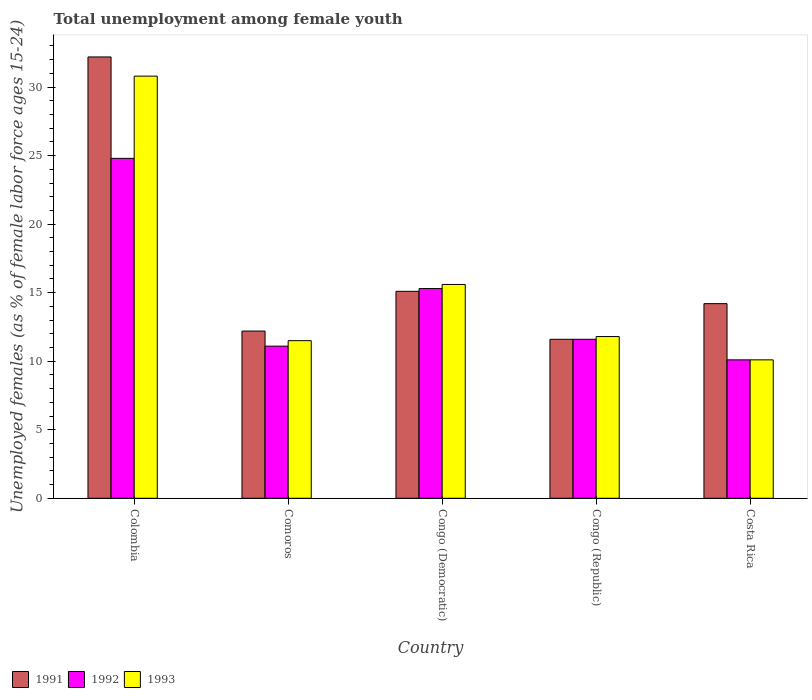How many groups of bars are there?
Offer a very short reply. 5. Are the number of bars per tick equal to the number of legend labels?
Provide a succinct answer. Yes. How many bars are there on the 2nd tick from the left?
Make the answer very short. 3. How many bars are there on the 4th tick from the right?
Provide a succinct answer. 3. What is the label of the 5th group of bars from the left?
Keep it short and to the point. Costa Rica. What is the percentage of unemployed females in in 1991 in Colombia?
Ensure brevity in your answer.  32.2. Across all countries, what is the maximum percentage of unemployed females in in 1991?
Give a very brief answer. 32.2. Across all countries, what is the minimum percentage of unemployed females in in 1992?
Provide a succinct answer. 10.1. In which country was the percentage of unemployed females in in 1993 minimum?
Your answer should be very brief. Costa Rica. What is the total percentage of unemployed females in in 1992 in the graph?
Keep it short and to the point. 72.9. What is the difference between the percentage of unemployed females in in 1992 in Congo (Democratic) and that in Congo (Republic)?
Provide a short and direct response. 3.7. What is the difference between the percentage of unemployed females in in 1993 in Congo (Democratic) and the percentage of unemployed females in in 1991 in Costa Rica?
Make the answer very short. 1.4. What is the average percentage of unemployed females in in 1991 per country?
Give a very brief answer. 17.06. What is the ratio of the percentage of unemployed females in in 1993 in Congo (Republic) to that in Costa Rica?
Offer a very short reply. 1.17. Is the percentage of unemployed females in in 1993 in Congo (Democratic) less than that in Congo (Republic)?
Provide a succinct answer. No. Is the difference between the percentage of unemployed females in in 1993 in Comoros and Congo (Republic) greater than the difference between the percentage of unemployed females in in 1992 in Comoros and Congo (Republic)?
Make the answer very short. Yes. What is the difference between the highest and the second highest percentage of unemployed females in in 1991?
Offer a very short reply. 18. What is the difference between the highest and the lowest percentage of unemployed females in in 1993?
Offer a very short reply. 20.7. What does the 2nd bar from the right in Costa Rica represents?
Make the answer very short. 1992. How many bars are there?
Keep it short and to the point. 15. What is the difference between two consecutive major ticks on the Y-axis?
Provide a short and direct response. 5. Are the values on the major ticks of Y-axis written in scientific E-notation?
Give a very brief answer. No. Does the graph contain any zero values?
Offer a very short reply. No. Does the graph contain grids?
Provide a short and direct response. No. How many legend labels are there?
Offer a very short reply. 3. What is the title of the graph?
Keep it short and to the point. Total unemployment among female youth. Does "1961" appear as one of the legend labels in the graph?
Make the answer very short. No. What is the label or title of the Y-axis?
Your answer should be compact. Unemployed females (as % of female labor force ages 15-24). What is the Unemployed females (as % of female labor force ages 15-24) in 1991 in Colombia?
Your answer should be very brief. 32.2. What is the Unemployed females (as % of female labor force ages 15-24) of 1992 in Colombia?
Provide a succinct answer. 24.8. What is the Unemployed females (as % of female labor force ages 15-24) in 1993 in Colombia?
Your response must be concise. 30.8. What is the Unemployed females (as % of female labor force ages 15-24) of 1991 in Comoros?
Offer a very short reply. 12.2. What is the Unemployed females (as % of female labor force ages 15-24) in 1992 in Comoros?
Your response must be concise. 11.1. What is the Unemployed females (as % of female labor force ages 15-24) of 1993 in Comoros?
Offer a terse response. 11.5. What is the Unemployed females (as % of female labor force ages 15-24) of 1991 in Congo (Democratic)?
Your answer should be compact. 15.1. What is the Unemployed females (as % of female labor force ages 15-24) in 1992 in Congo (Democratic)?
Offer a very short reply. 15.3. What is the Unemployed females (as % of female labor force ages 15-24) in 1993 in Congo (Democratic)?
Offer a very short reply. 15.6. What is the Unemployed females (as % of female labor force ages 15-24) of 1991 in Congo (Republic)?
Ensure brevity in your answer.  11.6. What is the Unemployed females (as % of female labor force ages 15-24) of 1992 in Congo (Republic)?
Offer a very short reply. 11.6. What is the Unemployed females (as % of female labor force ages 15-24) in 1993 in Congo (Republic)?
Give a very brief answer. 11.8. What is the Unemployed females (as % of female labor force ages 15-24) of 1991 in Costa Rica?
Ensure brevity in your answer.  14.2. What is the Unemployed females (as % of female labor force ages 15-24) of 1992 in Costa Rica?
Your answer should be very brief. 10.1. What is the Unemployed females (as % of female labor force ages 15-24) of 1993 in Costa Rica?
Give a very brief answer. 10.1. Across all countries, what is the maximum Unemployed females (as % of female labor force ages 15-24) in 1991?
Provide a succinct answer. 32.2. Across all countries, what is the maximum Unemployed females (as % of female labor force ages 15-24) in 1992?
Provide a succinct answer. 24.8. Across all countries, what is the maximum Unemployed females (as % of female labor force ages 15-24) of 1993?
Give a very brief answer. 30.8. Across all countries, what is the minimum Unemployed females (as % of female labor force ages 15-24) of 1991?
Your response must be concise. 11.6. Across all countries, what is the minimum Unemployed females (as % of female labor force ages 15-24) of 1992?
Provide a short and direct response. 10.1. Across all countries, what is the minimum Unemployed females (as % of female labor force ages 15-24) in 1993?
Your response must be concise. 10.1. What is the total Unemployed females (as % of female labor force ages 15-24) in 1991 in the graph?
Give a very brief answer. 85.3. What is the total Unemployed females (as % of female labor force ages 15-24) in 1992 in the graph?
Your answer should be compact. 72.9. What is the total Unemployed females (as % of female labor force ages 15-24) in 1993 in the graph?
Provide a succinct answer. 79.8. What is the difference between the Unemployed females (as % of female labor force ages 15-24) of 1992 in Colombia and that in Comoros?
Make the answer very short. 13.7. What is the difference between the Unemployed females (as % of female labor force ages 15-24) of 1993 in Colombia and that in Comoros?
Offer a terse response. 19.3. What is the difference between the Unemployed females (as % of female labor force ages 15-24) in 1993 in Colombia and that in Congo (Democratic)?
Ensure brevity in your answer.  15.2. What is the difference between the Unemployed females (as % of female labor force ages 15-24) of 1991 in Colombia and that in Congo (Republic)?
Give a very brief answer. 20.6. What is the difference between the Unemployed females (as % of female labor force ages 15-24) in 1993 in Colombia and that in Congo (Republic)?
Keep it short and to the point. 19. What is the difference between the Unemployed females (as % of female labor force ages 15-24) in 1991 in Colombia and that in Costa Rica?
Give a very brief answer. 18. What is the difference between the Unemployed females (as % of female labor force ages 15-24) in 1992 in Colombia and that in Costa Rica?
Your answer should be compact. 14.7. What is the difference between the Unemployed females (as % of female labor force ages 15-24) of 1993 in Colombia and that in Costa Rica?
Make the answer very short. 20.7. What is the difference between the Unemployed females (as % of female labor force ages 15-24) of 1993 in Comoros and that in Congo (Democratic)?
Offer a very short reply. -4.1. What is the difference between the Unemployed females (as % of female labor force ages 15-24) in 1991 in Comoros and that in Congo (Republic)?
Your response must be concise. 0.6. What is the difference between the Unemployed females (as % of female labor force ages 15-24) of 1992 in Comoros and that in Congo (Republic)?
Make the answer very short. -0.5. What is the difference between the Unemployed females (as % of female labor force ages 15-24) of 1991 in Congo (Democratic) and that in Congo (Republic)?
Provide a succinct answer. 3.5. What is the difference between the Unemployed females (as % of female labor force ages 15-24) of 1992 in Congo (Democratic) and that in Congo (Republic)?
Give a very brief answer. 3.7. What is the difference between the Unemployed females (as % of female labor force ages 15-24) of 1991 in Congo (Democratic) and that in Costa Rica?
Provide a succinct answer. 0.9. What is the difference between the Unemployed females (as % of female labor force ages 15-24) in 1992 in Congo (Democratic) and that in Costa Rica?
Your response must be concise. 5.2. What is the difference between the Unemployed females (as % of female labor force ages 15-24) of 1993 in Congo (Democratic) and that in Costa Rica?
Your response must be concise. 5.5. What is the difference between the Unemployed females (as % of female labor force ages 15-24) in 1991 in Congo (Republic) and that in Costa Rica?
Offer a very short reply. -2.6. What is the difference between the Unemployed females (as % of female labor force ages 15-24) in 1991 in Colombia and the Unemployed females (as % of female labor force ages 15-24) in 1992 in Comoros?
Your answer should be very brief. 21.1. What is the difference between the Unemployed females (as % of female labor force ages 15-24) of 1991 in Colombia and the Unemployed females (as % of female labor force ages 15-24) of 1993 in Comoros?
Your answer should be compact. 20.7. What is the difference between the Unemployed females (as % of female labor force ages 15-24) in 1992 in Colombia and the Unemployed females (as % of female labor force ages 15-24) in 1993 in Comoros?
Your response must be concise. 13.3. What is the difference between the Unemployed females (as % of female labor force ages 15-24) in 1991 in Colombia and the Unemployed females (as % of female labor force ages 15-24) in 1993 in Congo (Democratic)?
Offer a very short reply. 16.6. What is the difference between the Unemployed females (as % of female labor force ages 15-24) in 1992 in Colombia and the Unemployed females (as % of female labor force ages 15-24) in 1993 in Congo (Democratic)?
Provide a succinct answer. 9.2. What is the difference between the Unemployed females (as % of female labor force ages 15-24) of 1991 in Colombia and the Unemployed females (as % of female labor force ages 15-24) of 1992 in Congo (Republic)?
Your response must be concise. 20.6. What is the difference between the Unemployed females (as % of female labor force ages 15-24) in 1991 in Colombia and the Unemployed females (as % of female labor force ages 15-24) in 1993 in Congo (Republic)?
Give a very brief answer. 20.4. What is the difference between the Unemployed females (as % of female labor force ages 15-24) in 1992 in Colombia and the Unemployed females (as % of female labor force ages 15-24) in 1993 in Congo (Republic)?
Give a very brief answer. 13. What is the difference between the Unemployed females (as % of female labor force ages 15-24) in 1991 in Colombia and the Unemployed females (as % of female labor force ages 15-24) in 1992 in Costa Rica?
Offer a terse response. 22.1. What is the difference between the Unemployed females (as % of female labor force ages 15-24) of 1991 in Colombia and the Unemployed females (as % of female labor force ages 15-24) of 1993 in Costa Rica?
Provide a succinct answer. 22.1. What is the difference between the Unemployed females (as % of female labor force ages 15-24) of 1991 in Comoros and the Unemployed females (as % of female labor force ages 15-24) of 1992 in Congo (Democratic)?
Ensure brevity in your answer.  -3.1. What is the difference between the Unemployed females (as % of female labor force ages 15-24) of 1992 in Comoros and the Unemployed females (as % of female labor force ages 15-24) of 1993 in Congo (Democratic)?
Your response must be concise. -4.5. What is the difference between the Unemployed females (as % of female labor force ages 15-24) of 1991 in Comoros and the Unemployed females (as % of female labor force ages 15-24) of 1992 in Congo (Republic)?
Your answer should be very brief. 0.6. What is the difference between the Unemployed females (as % of female labor force ages 15-24) of 1991 in Comoros and the Unemployed females (as % of female labor force ages 15-24) of 1993 in Costa Rica?
Offer a very short reply. 2.1. What is the difference between the Unemployed females (as % of female labor force ages 15-24) of 1991 in Congo (Democratic) and the Unemployed females (as % of female labor force ages 15-24) of 1993 in Congo (Republic)?
Keep it short and to the point. 3.3. What is the difference between the Unemployed females (as % of female labor force ages 15-24) in 1992 in Congo (Democratic) and the Unemployed females (as % of female labor force ages 15-24) in 1993 in Costa Rica?
Give a very brief answer. 5.2. What is the difference between the Unemployed females (as % of female labor force ages 15-24) of 1991 in Congo (Republic) and the Unemployed females (as % of female labor force ages 15-24) of 1993 in Costa Rica?
Provide a succinct answer. 1.5. What is the average Unemployed females (as % of female labor force ages 15-24) in 1991 per country?
Keep it short and to the point. 17.06. What is the average Unemployed females (as % of female labor force ages 15-24) in 1992 per country?
Ensure brevity in your answer.  14.58. What is the average Unemployed females (as % of female labor force ages 15-24) of 1993 per country?
Your answer should be very brief. 15.96. What is the difference between the Unemployed females (as % of female labor force ages 15-24) in 1991 and Unemployed females (as % of female labor force ages 15-24) in 1992 in Colombia?
Give a very brief answer. 7.4. What is the difference between the Unemployed females (as % of female labor force ages 15-24) of 1992 and Unemployed females (as % of female labor force ages 15-24) of 1993 in Colombia?
Your answer should be compact. -6. What is the difference between the Unemployed females (as % of female labor force ages 15-24) of 1991 and Unemployed females (as % of female labor force ages 15-24) of 1993 in Comoros?
Your response must be concise. 0.7. What is the difference between the Unemployed females (as % of female labor force ages 15-24) in 1992 and Unemployed females (as % of female labor force ages 15-24) in 1993 in Comoros?
Provide a succinct answer. -0.4. What is the difference between the Unemployed females (as % of female labor force ages 15-24) of 1991 and Unemployed females (as % of female labor force ages 15-24) of 1992 in Congo (Democratic)?
Make the answer very short. -0.2. What is the difference between the Unemployed females (as % of female labor force ages 15-24) of 1992 and Unemployed females (as % of female labor force ages 15-24) of 1993 in Congo (Democratic)?
Keep it short and to the point. -0.3. What is the difference between the Unemployed females (as % of female labor force ages 15-24) of 1991 and Unemployed females (as % of female labor force ages 15-24) of 1992 in Congo (Republic)?
Give a very brief answer. 0. What is the difference between the Unemployed females (as % of female labor force ages 15-24) in 1991 and Unemployed females (as % of female labor force ages 15-24) in 1992 in Costa Rica?
Ensure brevity in your answer.  4.1. What is the difference between the Unemployed females (as % of female labor force ages 15-24) of 1991 and Unemployed females (as % of female labor force ages 15-24) of 1993 in Costa Rica?
Your answer should be compact. 4.1. What is the difference between the Unemployed females (as % of female labor force ages 15-24) in 1992 and Unemployed females (as % of female labor force ages 15-24) in 1993 in Costa Rica?
Keep it short and to the point. 0. What is the ratio of the Unemployed females (as % of female labor force ages 15-24) in 1991 in Colombia to that in Comoros?
Your response must be concise. 2.64. What is the ratio of the Unemployed females (as % of female labor force ages 15-24) in 1992 in Colombia to that in Comoros?
Provide a short and direct response. 2.23. What is the ratio of the Unemployed females (as % of female labor force ages 15-24) in 1993 in Colombia to that in Comoros?
Provide a succinct answer. 2.68. What is the ratio of the Unemployed females (as % of female labor force ages 15-24) of 1991 in Colombia to that in Congo (Democratic)?
Offer a very short reply. 2.13. What is the ratio of the Unemployed females (as % of female labor force ages 15-24) of 1992 in Colombia to that in Congo (Democratic)?
Offer a terse response. 1.62. What is the ratio of the Unemployed females (as % of female labor force ages 15-24) of 1993 in Colombia to that in Congo (Democratic)?
Provide a short and direct response. 1.97. What is the ratio of the Unemployed females (as % of female labor force ages 15-24) in 1991 in Colombia to that in Congo (Republic)?
Offer a terse response. 2.78. What is the ratio of the Unemployed females (as % of female labor force ages 15-24) in 1992 in Colombia to that in Congo (Republic)?
Provide a short and direct response. 2.14. What is the ratio of the Unemployed females (as % of female labor force ages 15-24) of 1993 in Colombia to that in Congo (Republic)?
Ensure brevity in your answer.  2.61. What is the ratio of the Unemployed females (as % of female labor force ages 15-24) in 1991 in Colombia to that in Costa Rica?
Offer a terse response. 2.27. What is the ratio of the Unemployed females (as % of female labor force ages 15-24) of 1992 in Colombia to that in Costa Rica?
Provide a succinct answer. 2.46. What is the ratio of the Unemployed females (as % of female labor force ages 15-24) in 1993 in Colombia to that in Costa Rica?
Give a very brief answer. 3.05. What is the ratio of the Unemployed females (as % of female labor force ages 15-24) in 1991 in Comoros to that in Congo (Democratic)?
Your answer should be very brief. 0.81. What is the ratio of the Unemployed females (as % of female labor force ages 15-24) in 1992 in Comoros to that in Congo (Democratic)?
Keep it short and to the point. 0.73. What is the ratio of the Unemployed females (as % of female labor force ages 15-24) of 1993 in Comoros to that in Congo (Democratic)?
Keep it short and to the point. 0.74. What is the ratio of the Unemployed females (as % of female labor force ages 15-24) in 1991 in Comoros to that in Congo (Republic)?
Your response must be concise. 1.05. What is the ratio of the Unemployed females (as % of female labor force ages 15-24) of 1992 in Comoros to that in Congo (Republic)?
Provide a succinct answer. 0.96. What is the ratio of the Unemployed females (as % of female labor force ages 15-24) of 1993 in Comoros to that in Congo (Republic)?
Your answer should be very brief. 0.97. What is the ratio of the Unemployed females (as % of female labor force ages 15-24) in 1991 in Comoros to that in Costa Rica?
Ensure brevity in your answer.  0.86. What is the ratio of the Unemployed females (as % of female labor force ages 15-24) in 1992 in Comoros to that in Costa Rica?
Give a very brief answer. 1.1. What is the ratio of the Unemployed females (as % of female labor force ages 15-24) in 1993 in Comoros to that in Costa Rica?
Your answer should be very brief. 1.14. What is the ratio of the Unemployed females (as % of female labor force ages 15-24) in 1991 in Congo (Democratic) to that in Congo (Republic)?
Give a very brief answer. 1.3. What is the ratio of the Unemployed females (as % of female labor force ages 15-24) in 1992 in Congo (Democratic) to that in Congo (Republic)?
Your answer should be very brief. 1.32. What is the ratio of the Unemployed females (as % of female labor force ages 15-24) in 1993 in Congo (Democratic) to that in Congo (Republic)?
Give a very brief answer. 1.32. What is the ratio of the Unemployed females (as % of female labor force ages 15-24) of 1991 in Congo (Democratic) to that in Costa Rica?
Offer a very short reply. 1.06. What is the ratio of the Unemployed females (as % of female labor force ages 15-24) of 1992 in Congo (Democratic) to that in Costa Rica?
Provide a short and direct response. 1.51. What is the ratio of the Unemployed females (as % of female labor force ages 15-24) in 1993 in Congo (Democratic) to that in Costa Rica?
Give a very brief answer. 1.54. What is the ratio of the Unemployed females (as % of female labor force ages 15-24) in 1991 in Congo (Republic) to that in Costa Rica?
Provide a short and direct response. 0.82. What is the ratio of the Unemployed females (as % of female labor force ages 15-24) in 1992 in Congo (Republic) to that in Costa Rica?
Make the answer very short. 1.15. What is the ratio of the Unemployed females (as % of female labor force ages 15-24) in 1993 in Congo (Republic) to that in Costa Rica?
Provide a short and direct response. 1.17. What is the difference between the highest and the second highest Unemployed females (as % of female labor force ages 15-24) of 1991?
Offer a terse response. 17.1. What is the difference between the highest and the lowest Unemployed females (as % of female labor force ages 15-24) of 1991?
Ensure brevity in your answer.  20.6. What is the difference between the highest and the lowest Unemployed females (as % of female labor force ages 15-24) in 1992?
Offer a terse response. 14.7. What is the difference between the highest and the lowest Unemployed females (as % of female labor force ages 15-24) in 1993?
Ensure brevity in your answer.  20.7. 